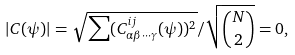Convert formula to latex. <formula><loc_0><loc_0><loc_500><loc_500>\left | C ( \psi ) \right | = \sqrt { \sum ( C _ { \alpha \beta \cdot \cdot \cdot \gamma } ^ { i j } ( \psi ) ) ^ { 2 } } / \sqrt { \binom { N } { 2 } } = 0 ,</formula> 